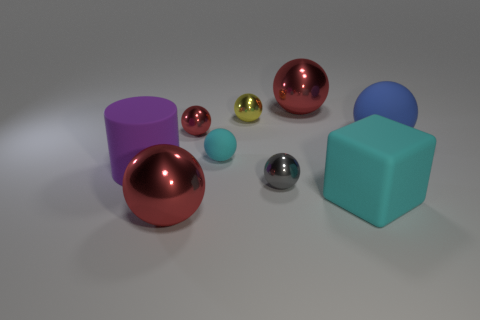Subtract all green blocks. How many red balls are left? 3 Subtract all cyan balls. How many balls are left? 6 Subtract all yellow metallic balls. How many balls are left? 6 Subtract all gray balls. Subtract all gray cylinders. How many balls are left? 6 Subtract all spheres. How many objects are left? 2 Add 5 large rubber balls. How many large rubber balls are left? 6 Add 6 small red cylinders. How many small red cylinders exist? 6 Subtract 0 blue cylinders. How many objects are left? 9 Subtract all large purple rubber cubes. Subtract all large rubber things. How many objects are left? 6 